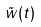<formula> <loc_0><loc_0><loc_500><loc_500>\tilde { w } ( t )</formula> 